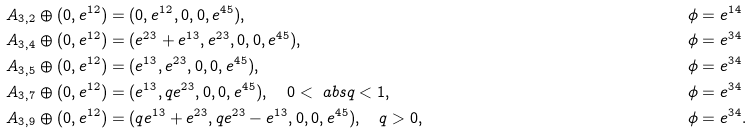<formula> <loc_0><loc_0><loc_500><loc_500>A _ { 3 , 2 } \oplus ( 0 , e ^ { 1 2 } ) & = ( 0 , e ^ { 1 2 } , 0 , 0 , e ^ { 4 5 } ) , & \phi & = e ^ { 1 4 } \\ A _ { 3 , 4 } \oplus ( 0 , e ^ { 1 2 } ) & = ( e ^ { 2 3 } + e ^ { 1 3 } , e ^ { 2 3 } , 0 , 0 , e ^ { 4 5 } ) , & \phi & = e ^ { 3 4 } \\ A _ { 3 , 5 } \oplus ( 0 , e ^ { 1 2 } ) & = ( e ^ { 1 3 } , e ^ { 2 3 } , 0 , 0 , e ^ { 4 5 } ) , & \phi & = e ^ { 3 4 } \\ A _ { 3 , 7 } \oplus ( 0 , e ^ { 1 2 } ) & = ( e ^ { 1 3 } , q e ^ { 2 3 } , 0 , 0 , e ^ { 4 5 } ) , \quad 0 < \ a b s { q } < 1 , & \phi & = e ^ { 3 4 } \\ A _ { 3 , 9 } \oplus ( 0 , e ^ { 1 2 } ) & = ( q e ^ { 1 3 } + e ^ { 2 3 } , q e ^ { 2 3 } - e ^ { 1 3 } , 0 , 0 , e ^ { 4 5 } ) , \quad q > 0 , & \phi & = e ^ { 3 4 } .</formula> 